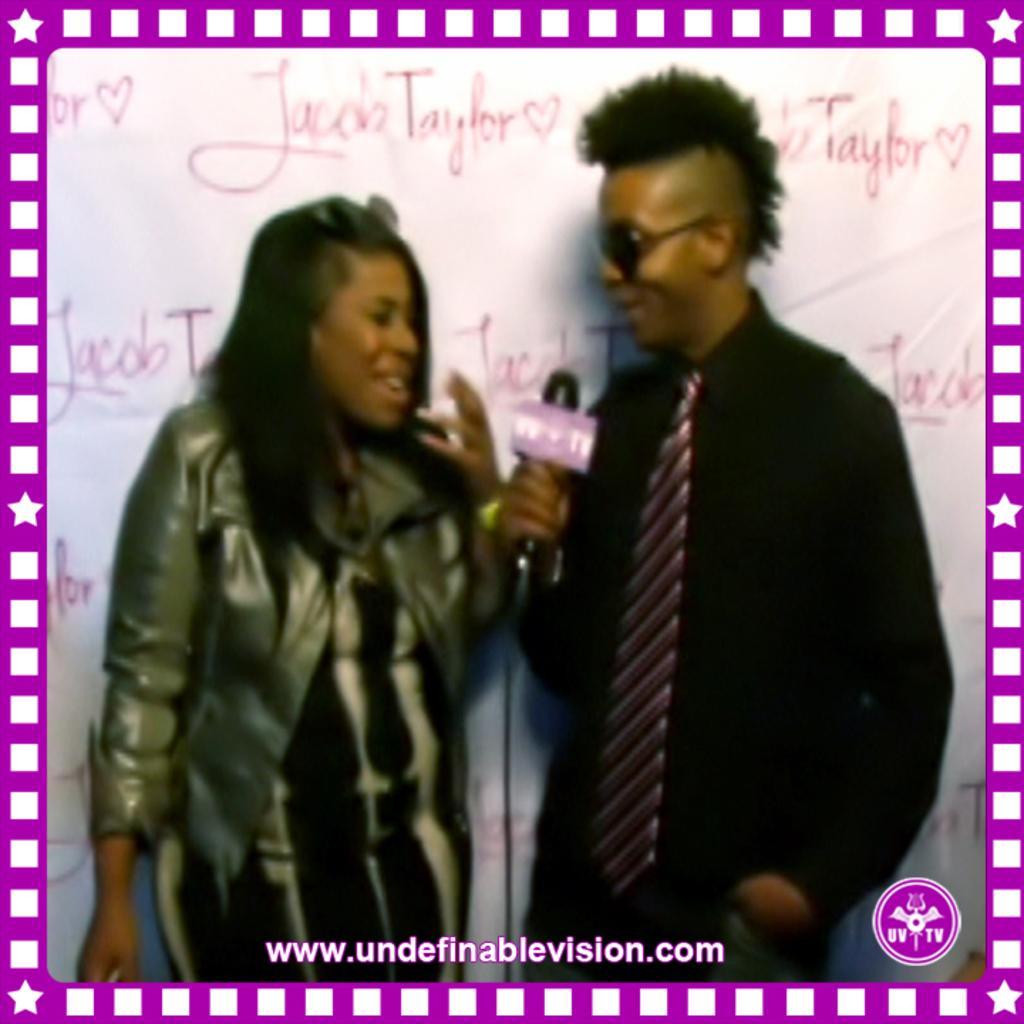Please provide a concise description of this image. This is the picture of a lady wearing jacket and a guy in black shirt and tie is holding the mic and behind there are some things written on the wall. 